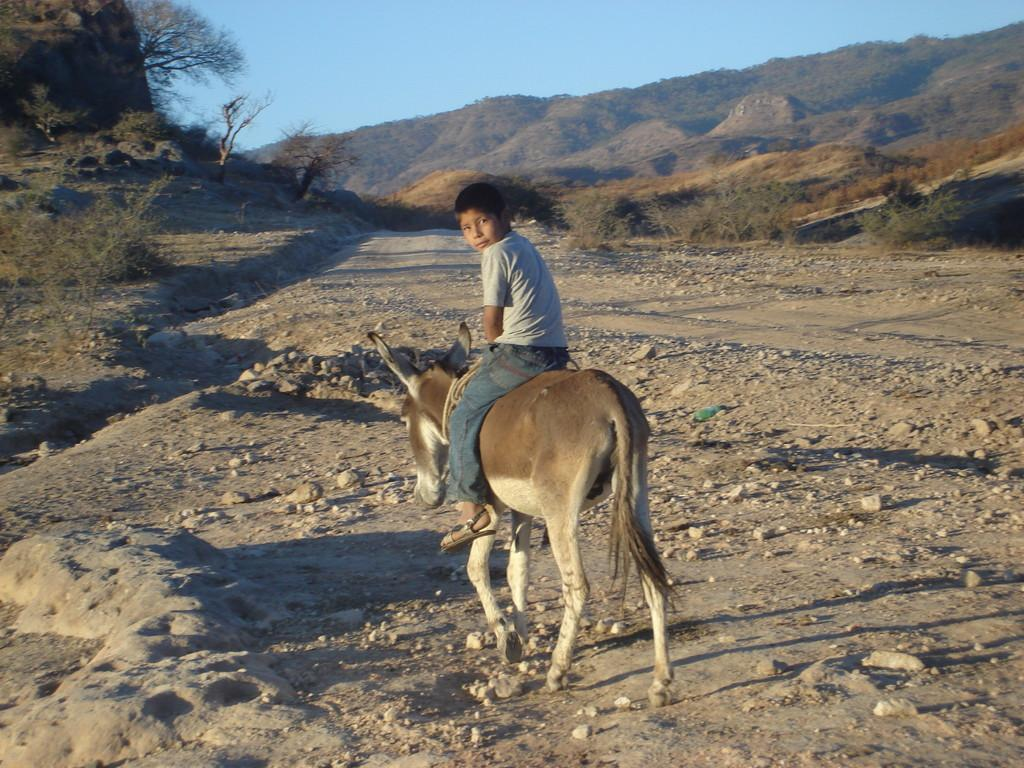Who is the main subject in the image? There is a boy in the image. What is the boy doing in the image? The boy is sitting on a donkey. What can be seen in the background of the image? There are trees, mountains, and the sky visible in the background of the image. What type of mark can be seen on the donkey's back in the image? There is no mark visible on the donkey's back in the image. What type of beam is supporting the trees in the background of the image? There is no beam present in the image; the trees are standing on their own. 